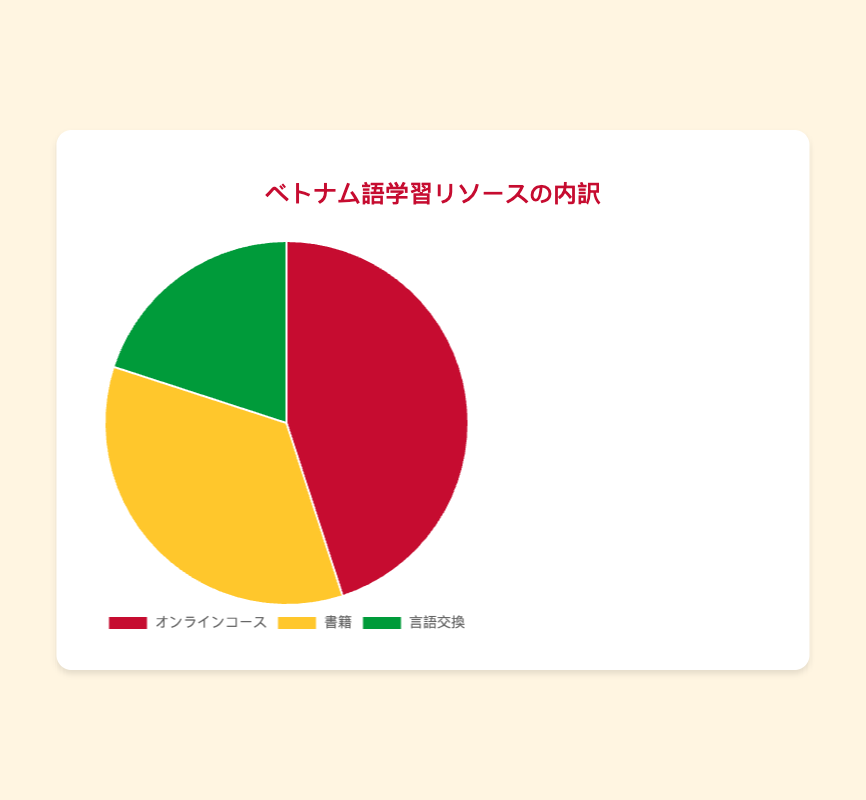What is the most used resource type for learning Vietnamese according to the pie chart? The largest section of the pie chart corresponds to the "オンラインコース" (Online Courses), which takes up 45% of the chart, indicating it is the most used resource type.
Answer: Online Courses Which resource type is represented by the yellow color in the pie chart? The pie chart's yellow section corresponds to "書籍" (Books), which is the second largest section and accounts for 35% of the chart.
Answer: Books How much more percentage do Online Courses account for compared to Language Exchange? The percentage for Online Courses is 45% while for Language Exchange is 20%. The difference is 45% - 20% = 25%.
Answer: 25% What is the combined percentage of Books and Language Exchange in the pie chart? The percentage for Books is 35% and for Language Exchange is 20%. The combined percentage is 35% + 20% = 55%.
Answer: 55% Which resource type has the smallest proportion in the pie chart? The smallest section of the pie chart is "言語交換" (Language Exchange), which accounts for 20% of the chart.
Answer: Language Exchange How many times larger is the proportion of Online Courses compared to Language Exchange in the pie chart? The proportion of Online Courses is 45% and Language Exchange is 20%. To find how many times larger Online Courses are, divide the two percentages: 45% ÷ 20% = 2.25.
Answer: 2.25 If the total percentage of resources used is 100%, what would be the percentage representation if the use of Books increased by 5%? The current percentage for Books is 35%. Increasing it by 5% makes it 35% + 5% = 40%.
Answer: 40% Which two resource types together cover more than half of the usage distribution in the pie chart? The percentages for Online Courses (45%) and Books (35%) together are 45% + 35% = 80%, which is more than half.
Answer: Online Courses and Books Visually, which section of the pie chart is the smallest in area? The smallest section in the pie chart by area is the green one, which corresponds to "言語交換" (Language Exchange), representing 20% of the total usage.
Answer: Green (Language Exchange) What percent increase in Language Exchange usage would equalize it with Online Courses? The current percentage for Language Exchange is 20%, and Online Courses is 45%. The difference is 45% - 20% = 25%. To find the percent increase needed to match Online Courses, calculate (25/20) * 100 = 125%.
Answer: 125% 